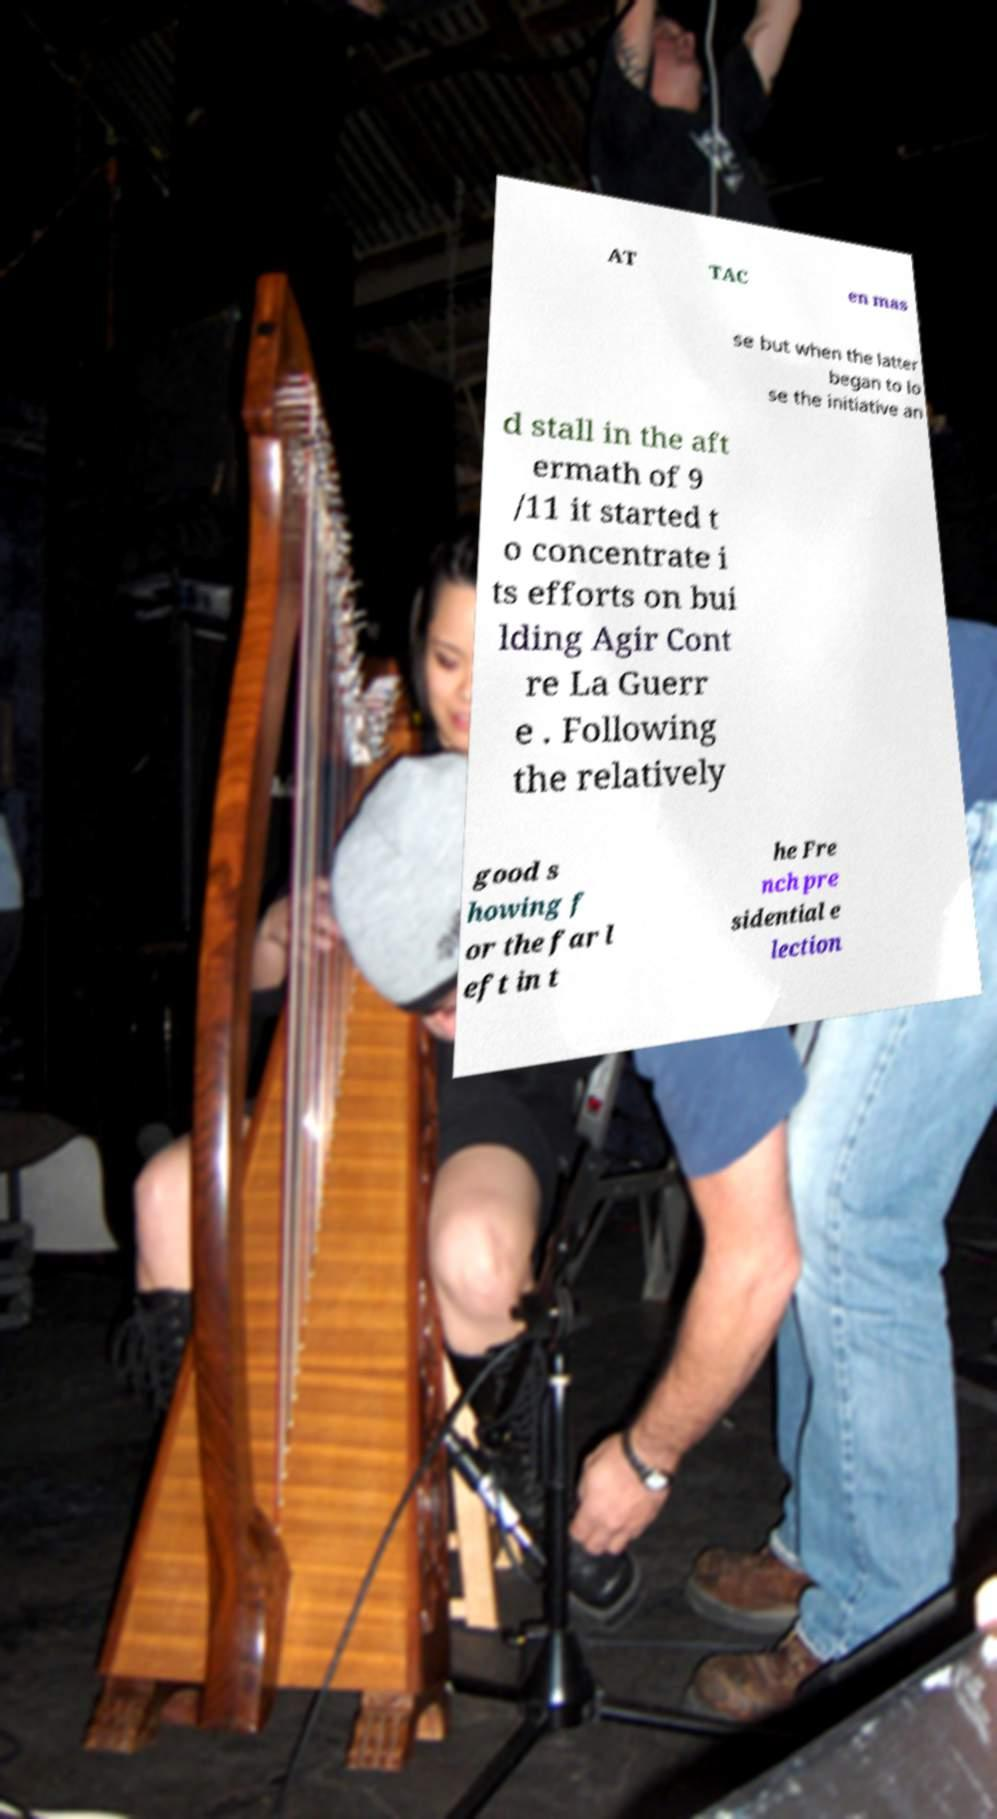Could you extract and type out the text from this image? AT TAC en mas se but when the latter began to lo se the initiative an d stall in the aft ermath of 9 /11 it started t o concentrate i ts efforts on bui lding Agir Cont re La Guerr e . Following the relatively good s howing f or the far l eft in t he Fre nch pre sidential e lection 